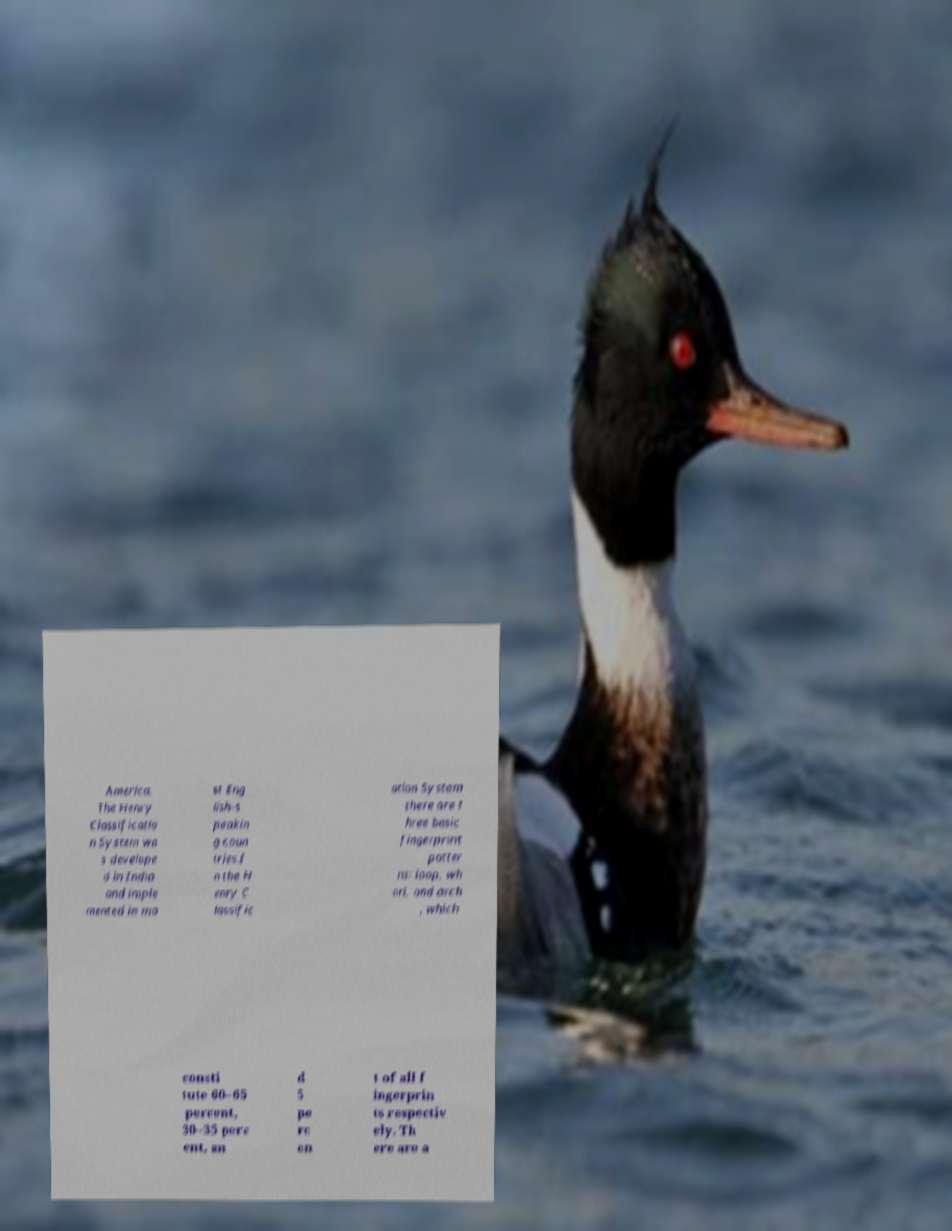Please identify and transcribe the text found in this image. America. The Henry Classificatio n System wa s develope d in India and imple mented in mo st Eng lish-s peakin g coun tries.I n the H enry C lassific ation System there are t hree basic fingerprint patter ns: loop, wh orl, and arch , which consti tute 60–65 percent, 30–35 perc ent, an d 5 pe rc en t of all f ingerprin ts respectiv ely. Th ere are a 